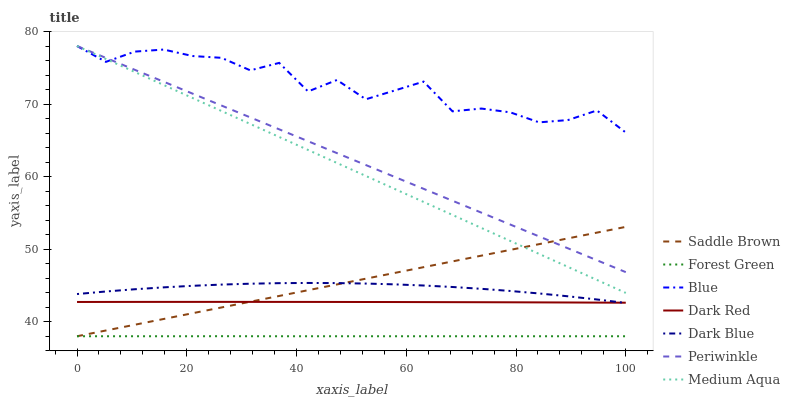Does Forest Green have the minimum area under the curve?
Answer yes or no. Yes. Does Blue have the maximum area under the curve?
Answer yes or no. Yes. Does Dark Red have the minimum area under the curve?
Answer yes or no. No. Does Dark Red have the maximum area under the curve?
Answer yes or no. No. Is Medium Aqua the smoothest?
Answer yes or no. Yes. Is Blue the roughest?
Answer yes or no. Yes. Is Dark Red the smoothest?
Answer yes or no. No. Is Dark Red the roughest?
Answer yes or no. No. Does Forest Green have the lowest value?
Answer yes or no. Yes. Does Dark Red have the lowest value?
Answer yes or no. No. Does Medium Aqua have the highest value?
Answer yes or no. Yes. Does Dark Red have the highest value?
Answer yes or no. No. Is Forest Green less than Periwinkle?
Answer yes or no. Yes. Is Blue greater than Dark Blue?
Answer yes or no. Yes. Does Periwinkle intersect Blue?
Answer yes or no. Yes. Is Periwinkle less than Blue?
Answer yes or no. No. Is Periwinkle greater than Blue?
Answer yes or no. No. Does Forest Green intersect Periwinkle?
Answer yes or no. No. 